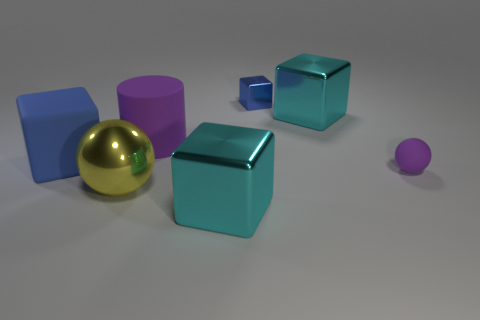Add 2 tiny brown metal cubes. How many objects exist? 9 Subtract all cylinders. How many objects are left? 6 Add 5 shiny spheres. How many shiny spheres are left? 6 Add 1 cyan metal cubes. How many cyan metal cubes exist? 3 Subtract 1 purple balls. How many objects are left? 6 Subtract all big metallic objects. Subtract all green balls. How many objects are left? 4 